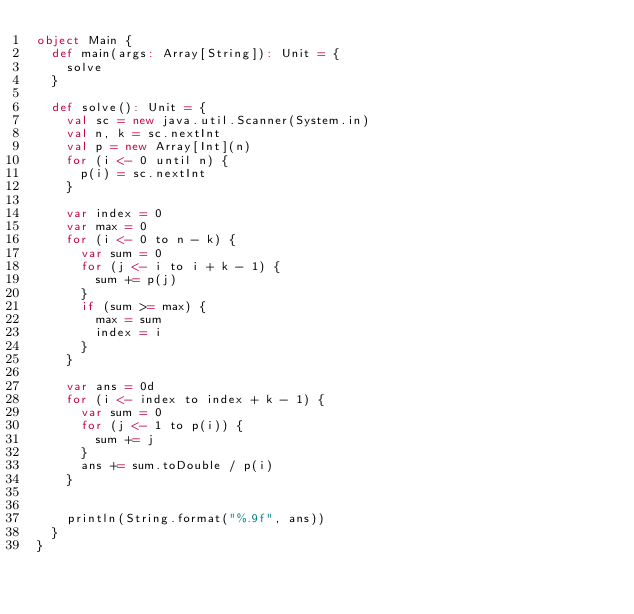Convert code to text. <code><loc_0><loc_0><loc_500><loc_500><_Scala_>object Main {
  def main(args: Array[String]): Unit = {
    solve
  }

  def solve(): Unit = {
    val sc = new java.util.Scanner(System.in)
    val n, k = sc.nextInt
    val p = new Array[Int](n)
    for (i <- 0 until n) {
      p(i) = sc.nextInt
    }

    var index = 0
    var max = 0
    for (i <- 0 to n - k) {
      var sum = 0
      for (j <- i to i + k - 1) {
        sum += p(j)
      }
      if (sum >= max) {
        max = sum
        index = i
      }
    }

    var ans = 0d
    for (i <- index to index + k - 1) {
      var sum = 0
      for (j <- 1 to p(i)) {
        sum += j
      }
      ans += sum.toDouble / p(i)
    }


    println(String.format("%.9f", ans))
  }
}
</code> 